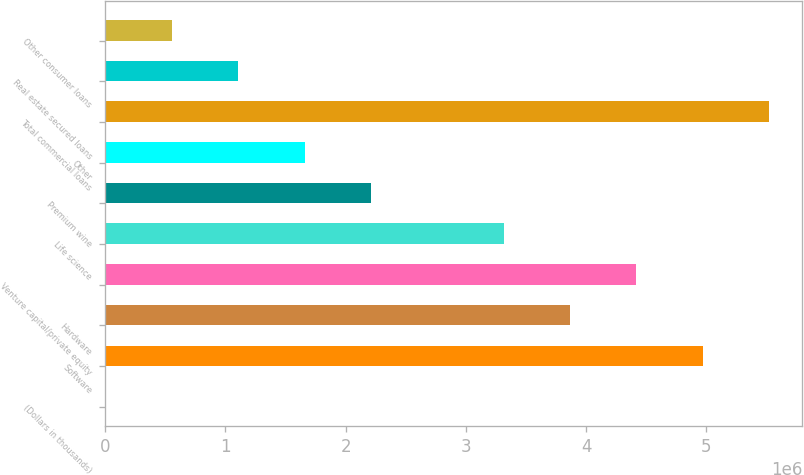<chart> <loc_0><loc_0><loc_500><loc_500><bar_chart><fcel>(Dollars in thousands)<fcel>Software<fcel>Hardware<fcel>Venture capital/private equity<fcel>Life science<fcel>Premium wine<fcel>Other<fcel>Total commercial loans<fcel>Real estate secured loans<fcel>Other consumer loans<nl><fcel>2010<fcel>4.96976e+06<fcel>3.86582e+06<fcel>4.41779e+06<fcel>3.31385e+06<fcel>2.2099e+06<fcel>1.65793e+06<fcel>5.52174e+06<fcel>1.10596e+06<fcel>553983<nl></chart> 